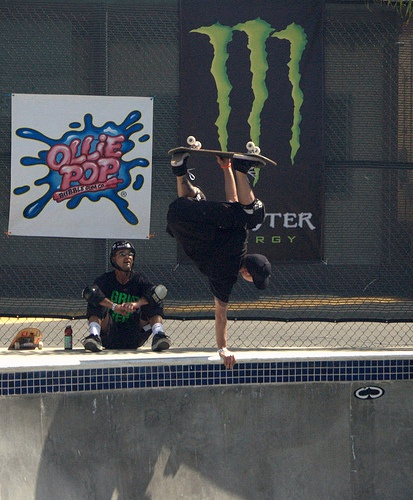Describe the objects in this image and their specific colors. I can see people in black, gray, and maroon tones, people in black, gray, maroon, and darkgray tones, skateboard in black, gray, and darkgray tones, skateboard in black, gray, and maroon tones, and bottle in black, gray, maroon, and teal tones in this image. 